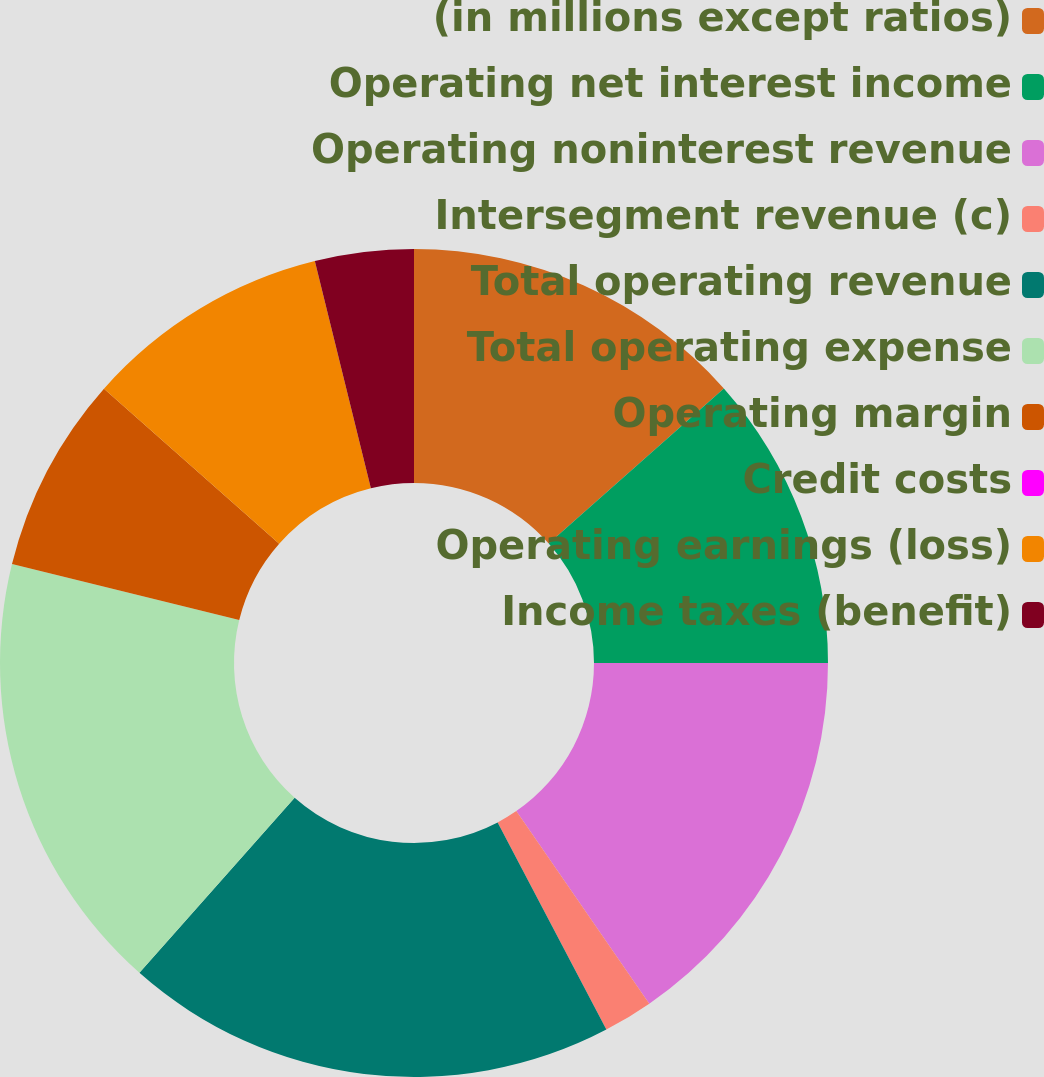Convert chart. <chart><loc_0><loc_0><loc_500><loc_500><pie_chart><fcel>(in millions except ratios)<fcel>Operating net interest income<fcel>Operating noninterest revenue<fcel>Intersegment revenue (c)<fcel>Total operating revenue<fcel>Total operating expense<fcel>Operating margin<fcel>Credit costs<fcel>Operating earnings (loss)<fcel>Income taxes (benefit)<nl><fcel>13.46%<fcel>11.54%<fcel>15.38%<fcel>1.93%<fcel>19.23%<fcel>17.3%<fcel>7.69%<fcel>0.0%<fcel>9.62%<fcel>3.85%<nl></chart> 